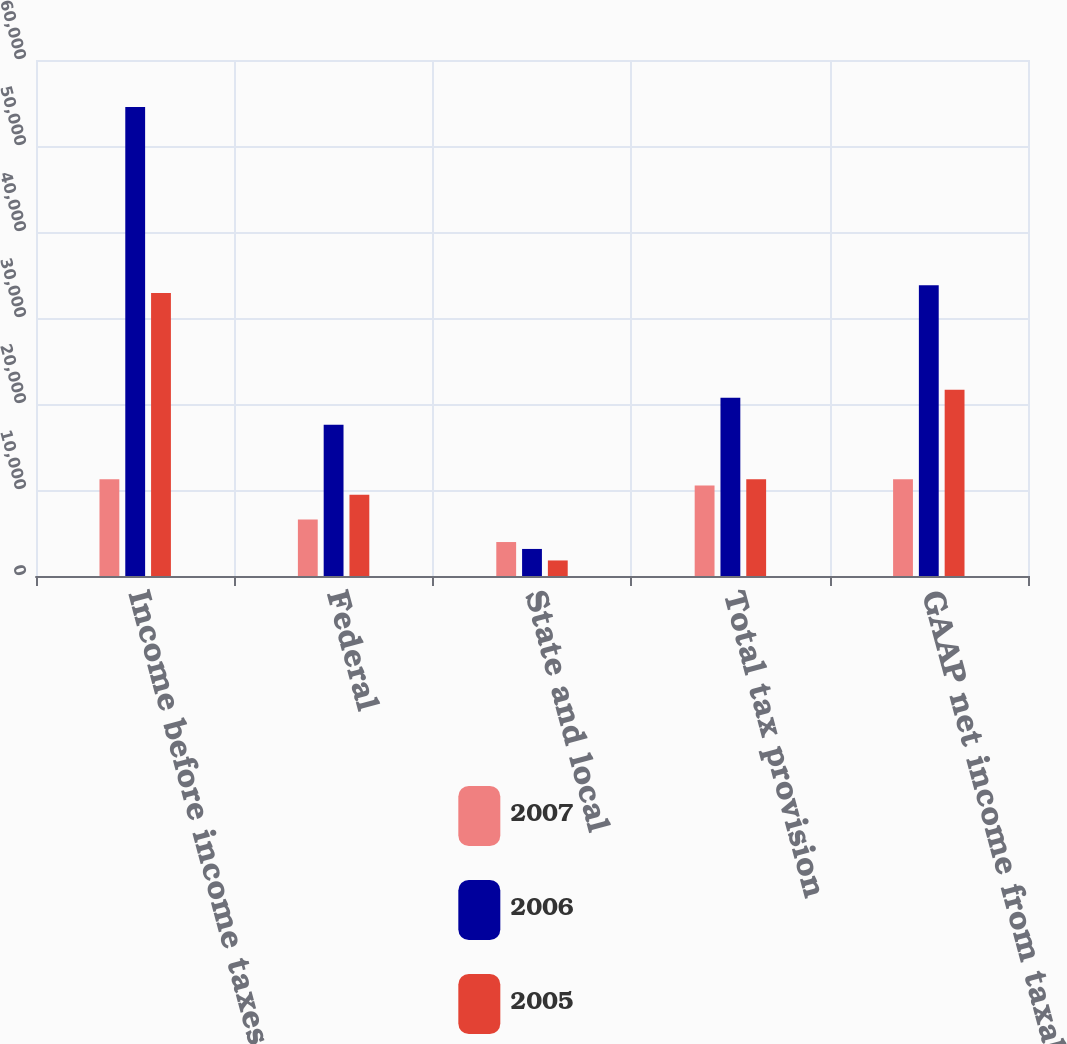Convert chart to OTSL. <chart><loc_0><loc_0><loc_500><loc_500><stacked_bar_chart><ecel><fcel>Income before income taxes<fcel>Federal<fcel>State and local<fcel>Total tax provision<fcel>GAAP net income from taxable<nl><fcel>2007<fcel>11254<fcel>6565<fcel>3950<fcel>10515<fcel>11254<nl><fcel>2006<fcel>54522<fcel>17581<fcel>3146<fcel>20727<fcel>33795<nl><fcel>2005<fcel>32920<fcel>9446<fcel>1808<fcel>11254<fcel>21666<nl></chart> 